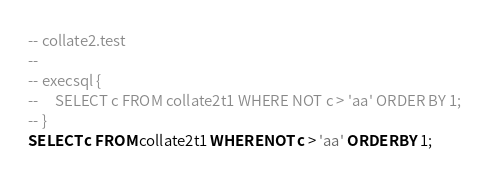<code> <loc_0><loc_0><loc_500><loc_500><_SQL_>-- collate2.test
-- 
-- execsql {
--     SELECT c FROM collate2t1 WHERE NOT c > 'aa' ORDER BY 1;
-- }
SELECT c FROM collate2t1 WHERE NOT c > 'aa' ORDER BY 1;</code> 